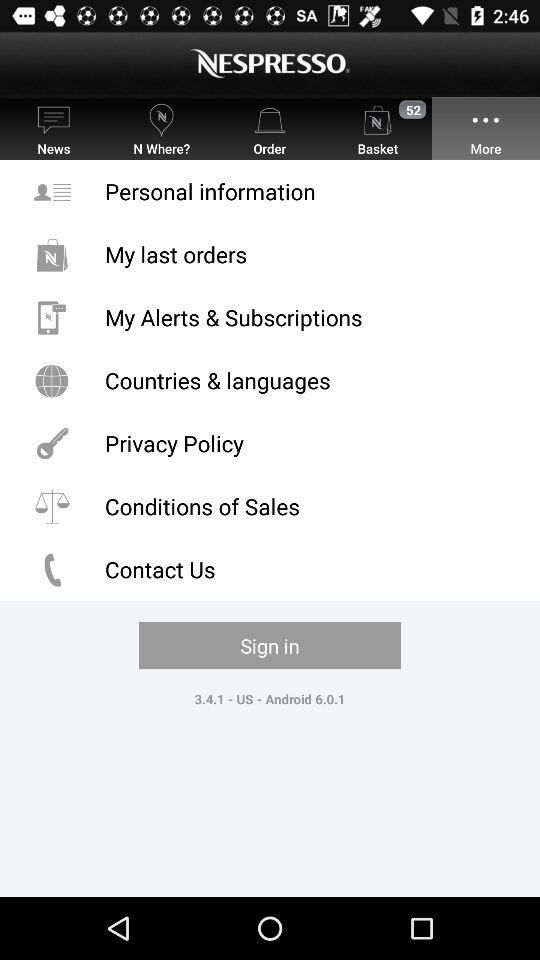Which tab is selected? The selected tab is "More". 